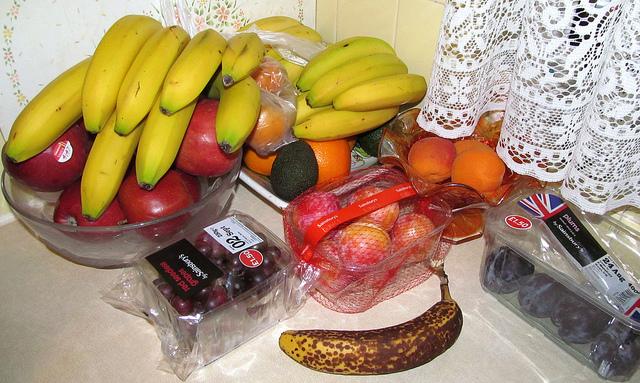Are bananas in the bag?
Short answer required. No. Is this healthy?
Short answer required. Yes. What country is this photo from?
Give a very brief answer. England. Is this cluttered?
Be succinct. Yes. Where are the apples?
Give a very brief answer. Under bananas. 